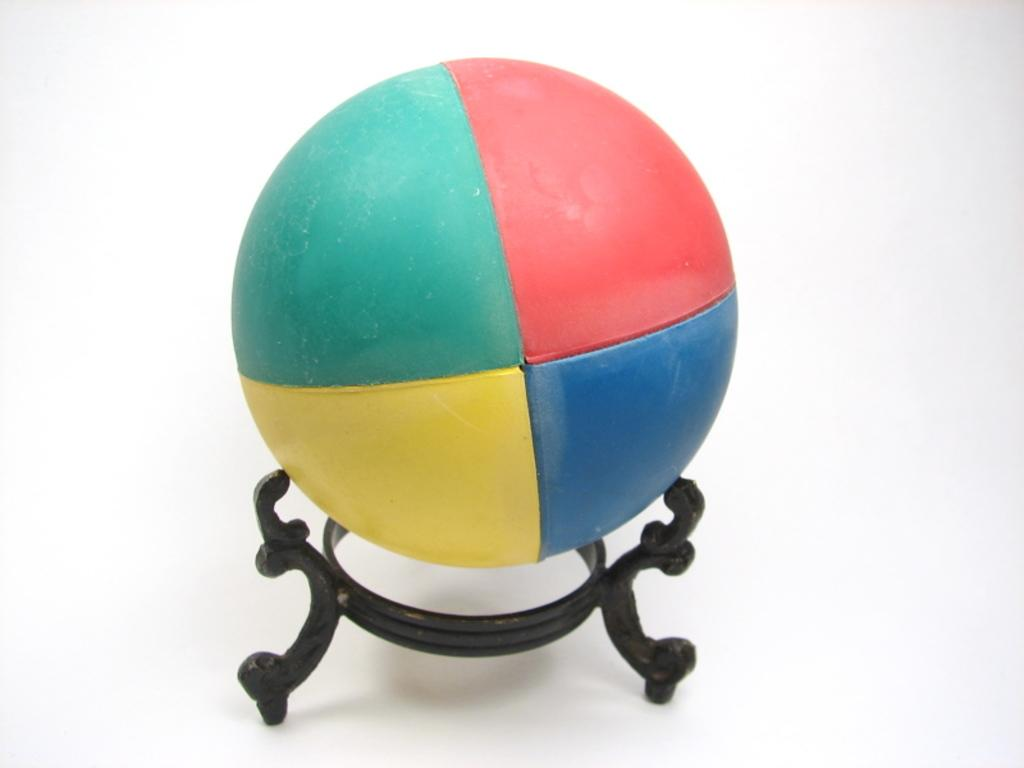What object is the main focus of the image? There is a ball in the image. What is the ball resting on? The ball is on a black color stand. What color is the background of the image? The background of the image is white. How many passengers are visible in the image? There are no passengers present in the image; it features a ball on a stand with a white background. What type of root is growing from the ball in the image? There is no root growing from the ball in the image; it is simply resting on a black stand. 